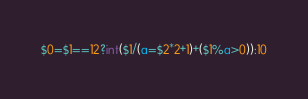Convert code to text. <code><loc_0><loc_0><loc_500><loc_500><_Awk_>$0=$1==12?int($1/(a=$2*2+1)+($1%a>0)):10</code> 